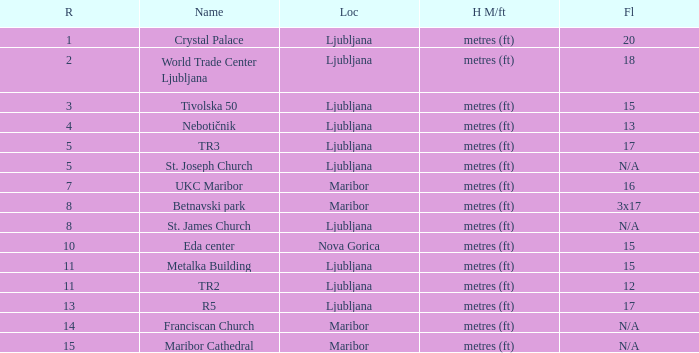Which Height Metres / feet has a Rank of 8, and Floors of 3x17? Metres (ft). 